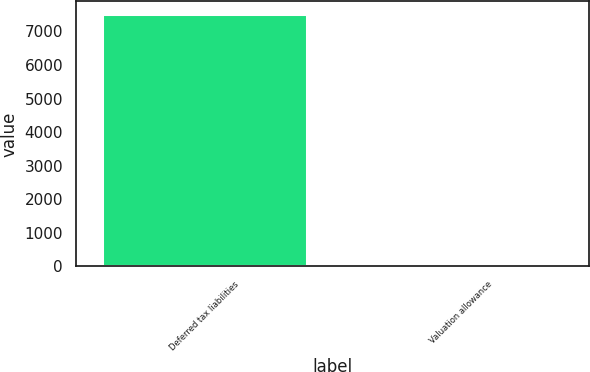<chart> <loc_0><loc_0><loc_500><loc_500><bar_chart><fcel>Deferred tax liabilities<fcel>Valuation allowance<nl><fcel>7516<fcel>12<nl></chart> 